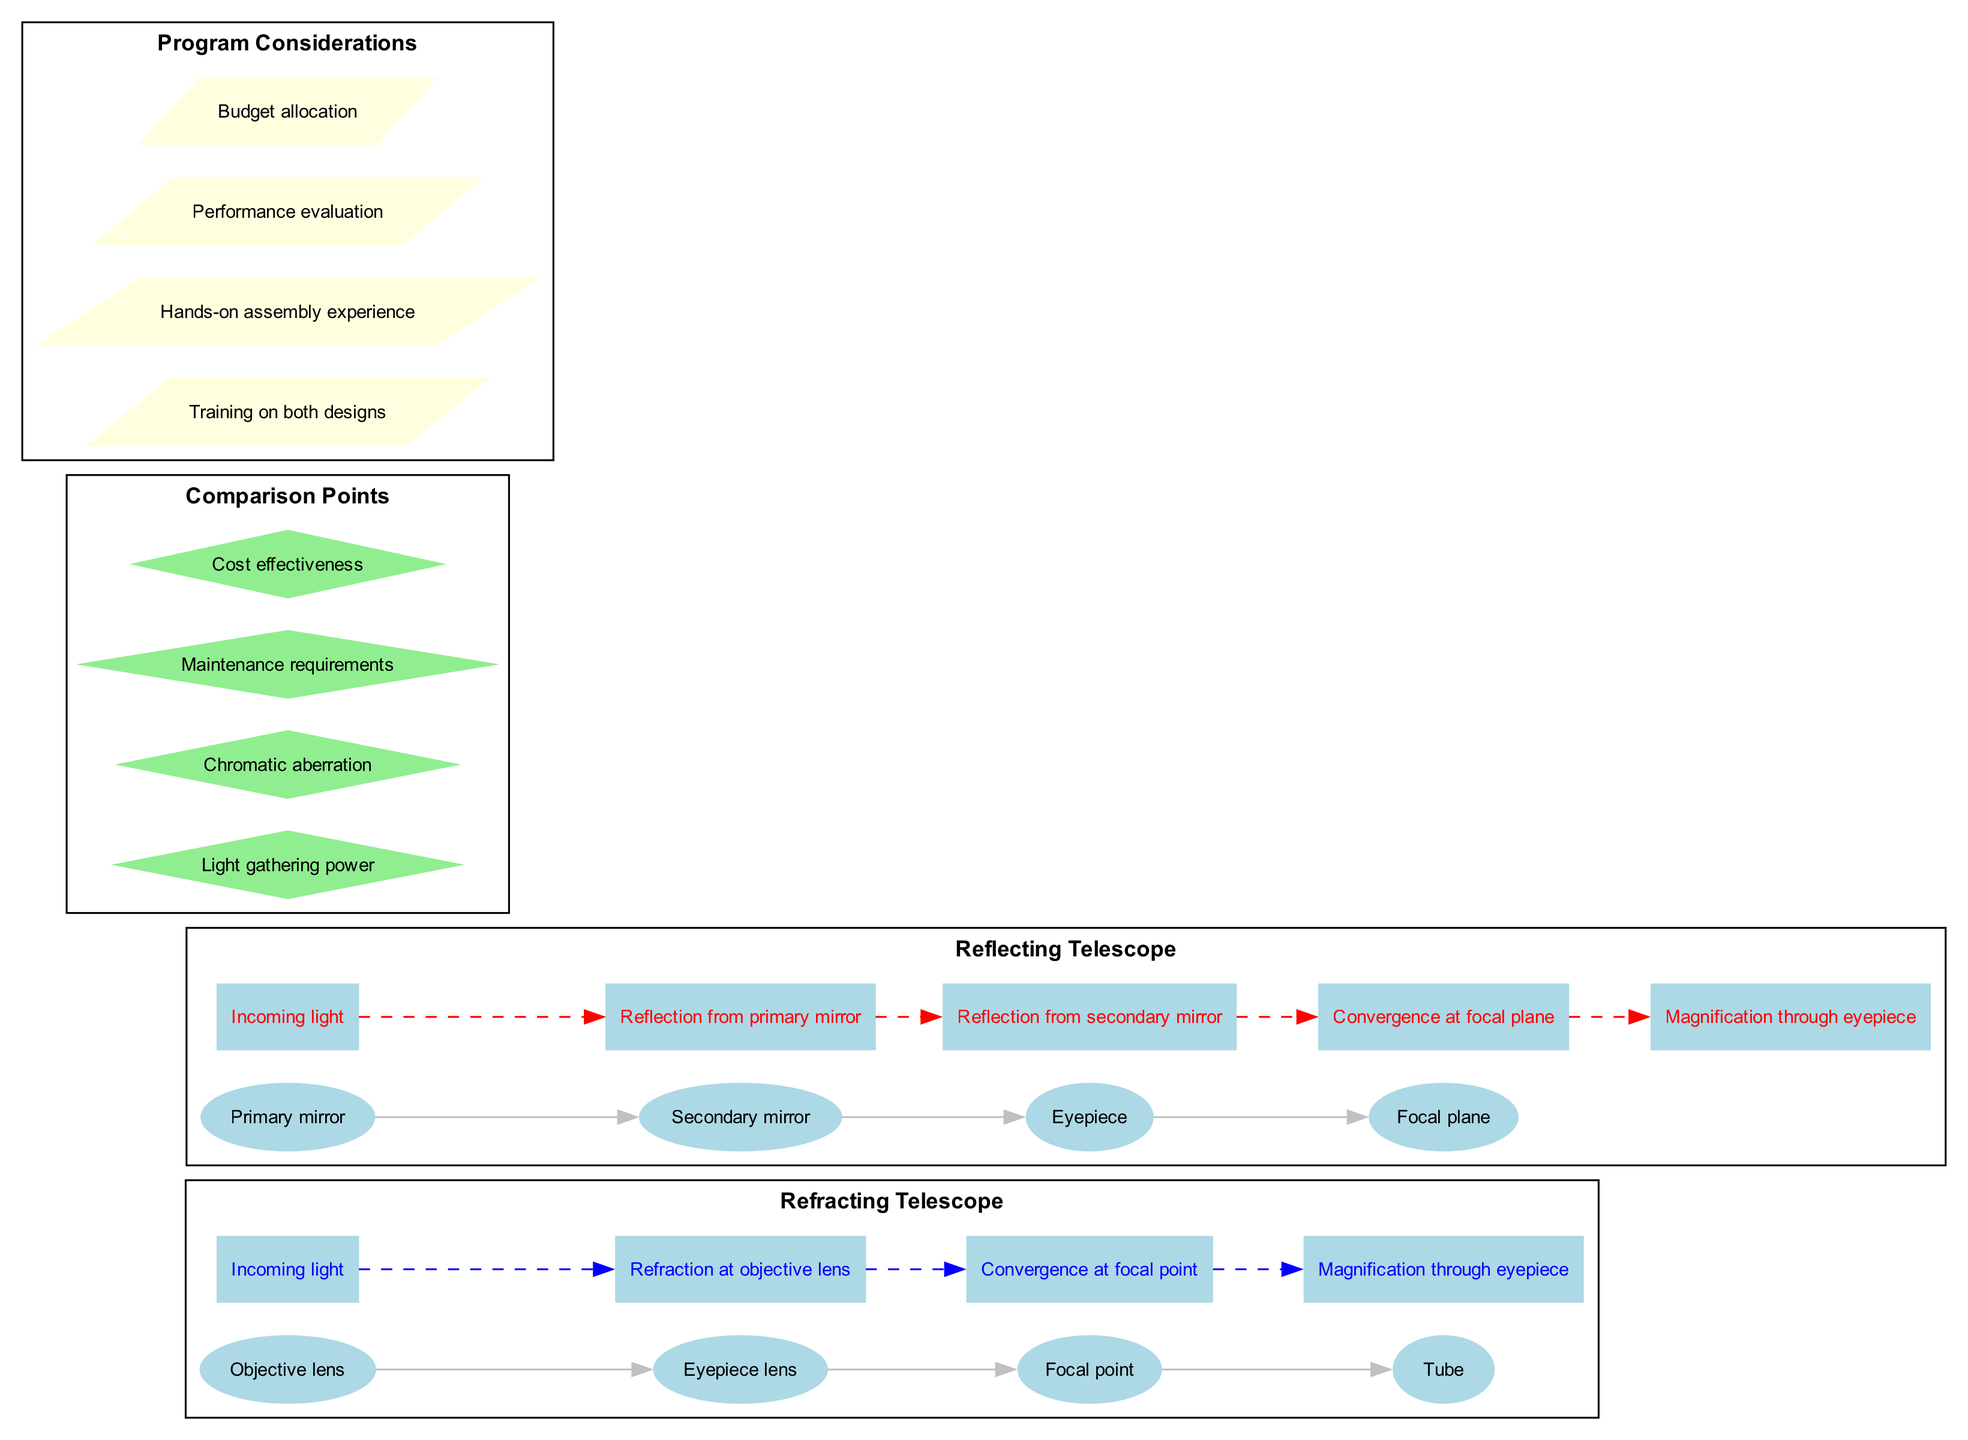What are the main components of the refracting telescope? The components of the refracting telescope are listed in the diagram: Objective lens, Eyepiece lens, Focal point, Tube. These components are shown in a sequence which indicates their arrangement in the design.
Answer: Objective lens, Eyepiece lens, Focal point, Tube What is used to gather incoming light in the reflecting telescope? The primary mirror is the component responsible for gathering incoming light in the reflecting telescope as indicated in the diagram. It is the first element encountered by light entering the telescope.
Answer: Primary mirror How many total components are there in the reflecting telescope? The diagram lists four components for the reflecting telescope: Primary mirror, Secondary mirror, Eyepiece, and Focal plane. Counting these gives a total of four components.
Answer: 4 Which telescope design has less chromatic aberration? The diagram implies that reflecting telescopes generally have less chromatic aberration as they use mirrors rather than lenses. This statement is based on the comparison points provided in the diagram.
Answer: Reflecting What is the light path of a refracting telescope? The light path for a refracting telescope, as shown in the diagram, encompasses the following steps: Incoming light, Refraction at objective lens, Convergence at focal point, Magnification through eyepiece. These steps outline how light travels through the telescope.
Answer: Incoming light, Refraction at objective lens, Convergence at focal point, Magnification through eyepiece Which telescope requires more maintenance according to the diagram? Based on the comparison points, the diagram suggests refracting telescopes require more maintenance than reflecting telescopes. This can be inferred from the general understanding of how lenses can misalign and collect dust more easily than mirrors.
Answer: Refracting What actions are included in the program considerations? The diagram lists four program considerations: Training on both designs, Hands-on assembly experience, Performance evaluation, Budget allocation. These aspects are critical for effective transition in the program.
Answer: Training on both designs, Hands-on assembly experience, Performance evaluation, Budget allocation Which component in the reflecting telescope reflects light twice before reaching the eyepiece? The light path indicates that light is first reflected by the primary mirror and then by the secondary mirror before reaching the eyepiece. This sequential reflection is crucial for the functioning of the reflecting telescope.
Answer: Secondary mirror What is the main purpose of the eyepiece in both telescope designs? The eyepiece functions to magnify the image formed by the telescope, allowing the observer to see a larger and clearer view of the celestial object being observed in both designs. This is derived from the same information in both light paths.
Answer: Magnification 